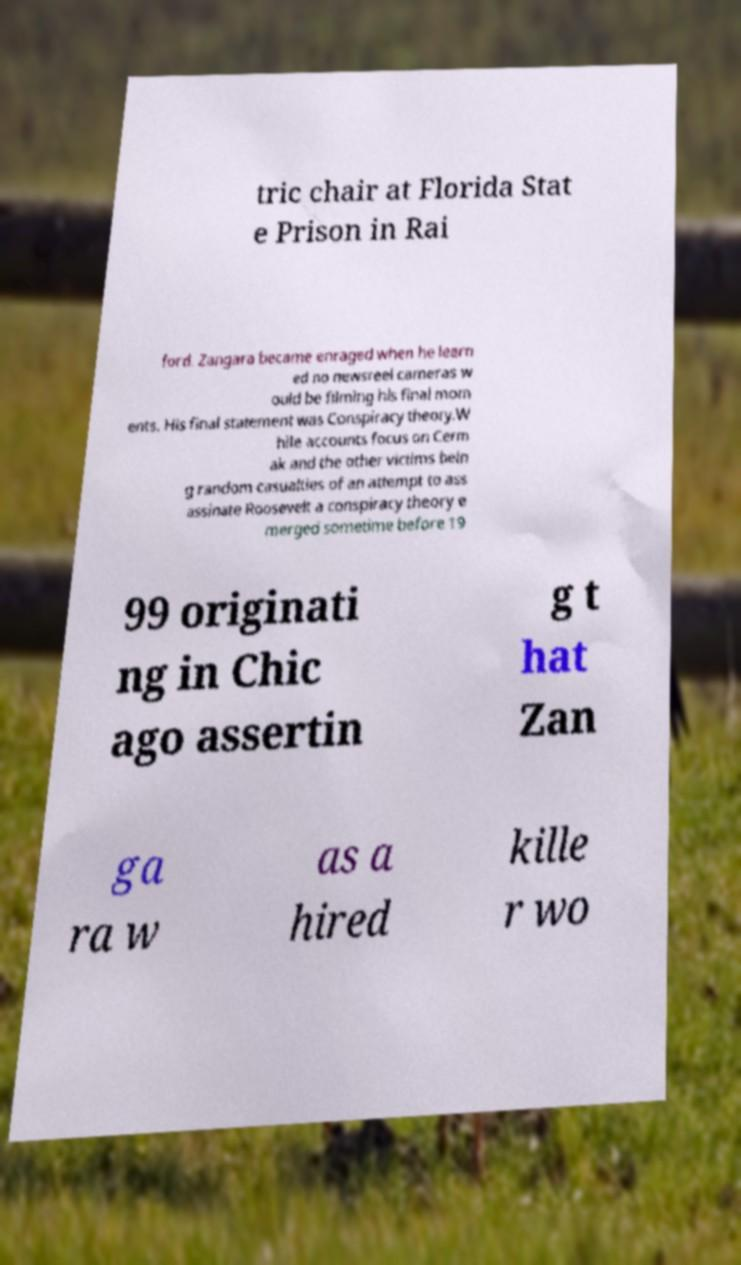Could you assist in decoding the text presented in this image and type it out clearly? tric chair at Florida Stat e Prison in Rai ford. Zangara became enraged when he learn ed no newsreel cameras w ould be filming his final mom ents. His final statement was Conspiracy theory.W hile accounts focus on Cerm ak and the other victims bein g random casualties of an attempt to ass assinate Roosevelt a conspiracy theory e merged sometime before 19 99 originati ng in Chic ago assertin g t hat Zan ga ra w as a hired kille r wo 